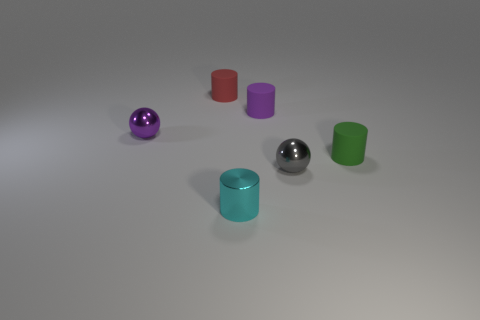Add 4 green cylinders. How many objects exist? 10 Subtract all cylinders. How many objects are left? 2 Add 6 metal balls. How many metal balls are left? 8 Add 2 small gray objects. How many small gray objects exist? 3 Subtract 0 purple cubes. How many objects are left? 6 Subtract all tiny rubber spheres. Subtract all tiny green cylinders. How many objects are left? 5 